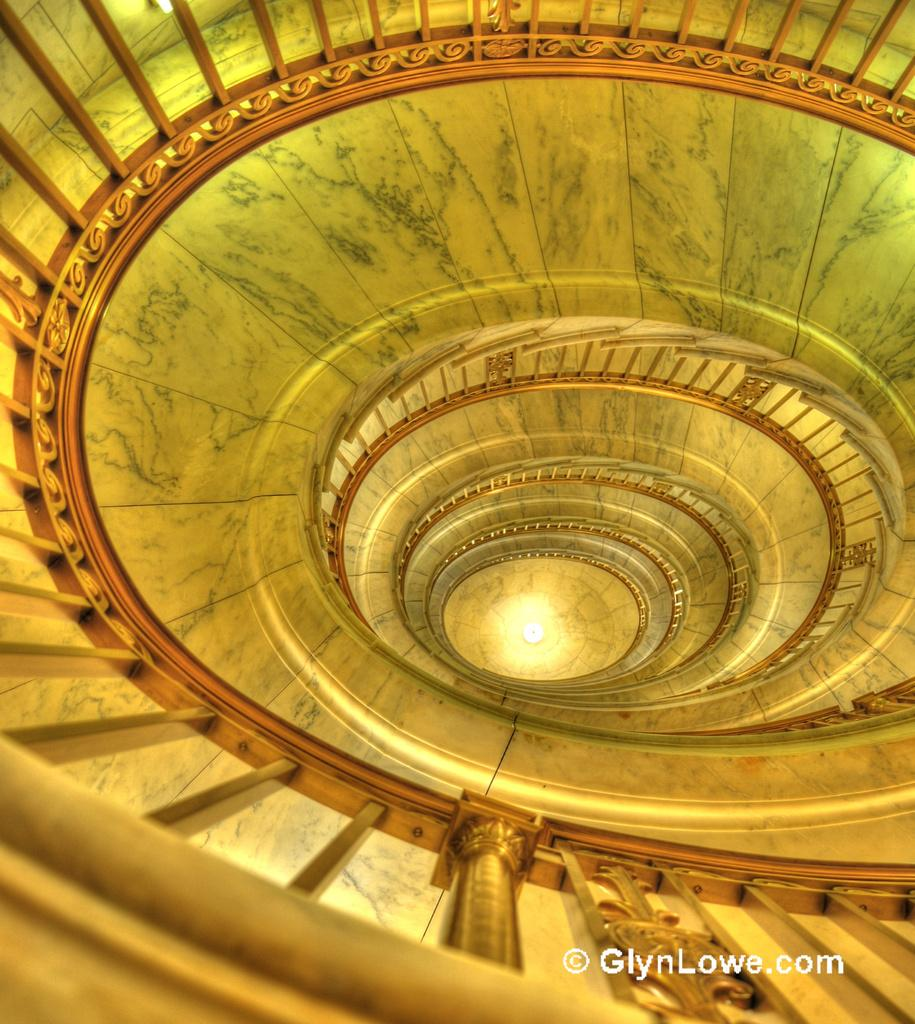What type of structure is present in the image? There is a staircase in the image. Can you describe the staircase in more detail? The provided facts do not offer additional details about the staircase. What might the purpose of the staircase be? The staircase could be used for accessing different levels of a building or structure. What type of punishment is being administered at the top of the staircase in the image? There is no indication of punishment or any related activity in the image; it only features a staircase. 